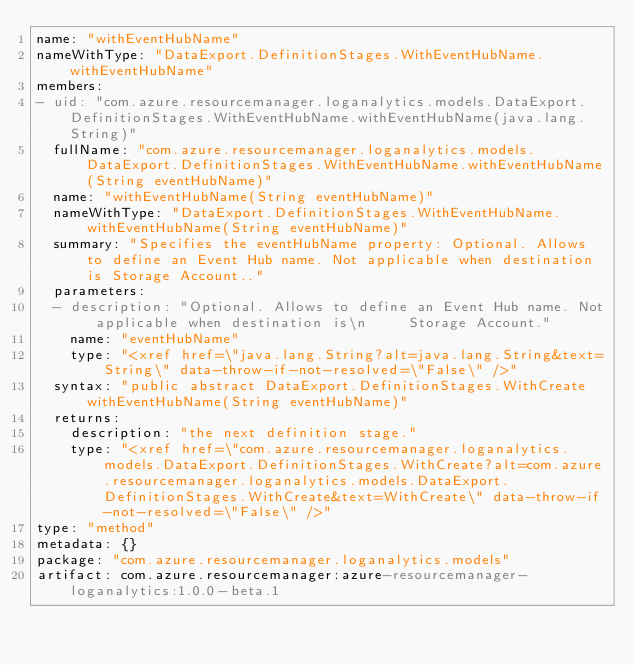<code> <loc_0><loc_0><loc_500><loc_500><_YAML_>name: "withEventHubName"
nameWithType: "DataExport.DefinitionStages.WithEventHubName.withEventHubName"
members:
- uid: "com.azure.resourcemanager.loganalytics.models.DataExport.DefinitionStages.WithEventHubName.withEventHubName(java.lang.String)"
  fullName: "com.azure.resourcemanager.loganalytics.models.DataExport.DefinitionStages.WithEventHubName.withEventHubName(String eventHubName)"
  name: "withEventHubName(String eventHubName)"
  nameWithType: "DataExport.DefinitionStages.WithEventHubName.withEventHubName(String eventHubName)"
  summary: "Specifies the eventHubName property: Optional. Allows to define an Event Hub name. Not applicable when destination is Storage Account.."
  parameters:
  - description: "Optional. Allows to define an Event Hub name. Not applicable when destination is\n     Storage Account."
    name: "eventHubName"
    type: "<xref href=\"java.lang.String?alt=java.lang.String&text=String\" data-throw-if-not-resolved=\"False\" />"
  syntax: "public abstract DataExport.DefinitionStages.WithCreate withEventHubName(String eventHubName)"
  returns:
    description: "the next definition stage."
    type: "<xref href=\"com.azure.resourcemanager.loganalytics.models.DataExport.DefinitionStages.WithCreate?alt=com.azure.resourcemanager.loganalytics.models.DataExport.DefinitionStages.WithCreate&text=WithCreate\" data-throw-if-not-resolved=\"False\" />"
type: "method"
metadata: {}
package: "com.azure.resourcemanager.loganalytics.models"
artifact: com.azure.resourcemanager:azure-resourcemanager-loganalytics:1.0.0-beta.1
</code> 